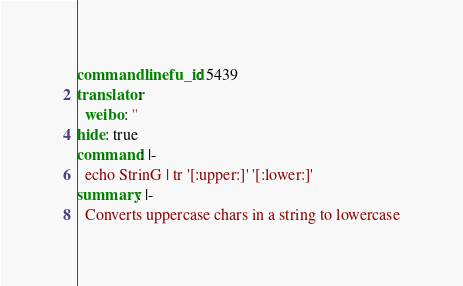Convert code to text. <code><loc_0><loc_0><loc_500><loc_500><_YAML_>commandlinefu_id: 5439
translator:
  weibo: ''
hide: true
command: |-
  echo StrinG | tr '[:upper:]' '[:lower:]'
summary: |-
  Converts uppercase chars in a string to lowercase
</code> 